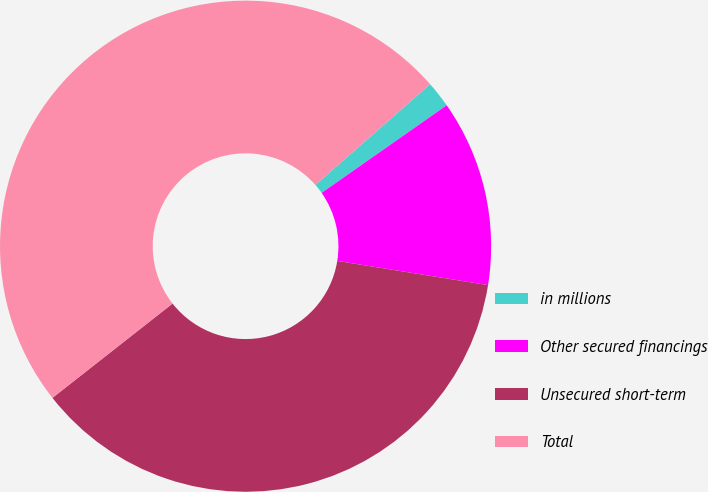Convert chart. <chart><loc_0><loc_0><loc_500><loc_500><pie_chart><fcel>in millions<fcel>Other secured financings<fcel>Unsecured short-term<fcel>Total<nl><fcel>1.74%<fcel>12.26%<fcel>36.87%<fcel>49.13%<nl></chart> 